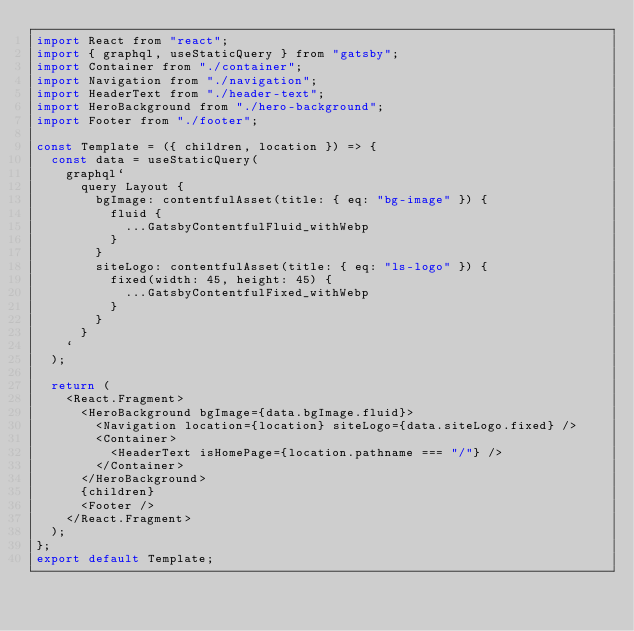<code> <loc_0><loc_0><loc_500><loc_500><_JavaScript_>import React from "react";
import { graphql, useStaticQuery } from "gatsby";
import Container from "./container";
import Navigation from "./navigation";
import HeaderText from "./header-text";
import HeroBackground from "./hero-background";
import Footer from "./footer";

const Template = ({ children, location }) => {
  const data = useStaticQuery(
    graphql`
      query Layout {
        bgImage: contentfulAsset(title: { eq: "bg-image" }) {
          fluid {
            ...GatsbyContentfulFluid_withWebp
          }
        }
        siteLogo: contentfulAsset(title: { eq: "ls-logo" }) {
          fixed(width: 45, height: 45) {
            ...GatsbyContentfulFixed_withWebp
          }
        }
      }
    `
  );

  return (
    <React.Fragment>
      <HeroBackground bgImage={data.bgImage.fluid}>
        <Navigation location={location} siteLogo={data.siteLogo.fixed} />
        <Container>
          <HeaderText isHomePage={location.pathname === "/"} />
        </Container>
      </HeroBackground>
      {children}
      <Footer />
    </React.Fragment>
  );
};
export default Template;
</code> 